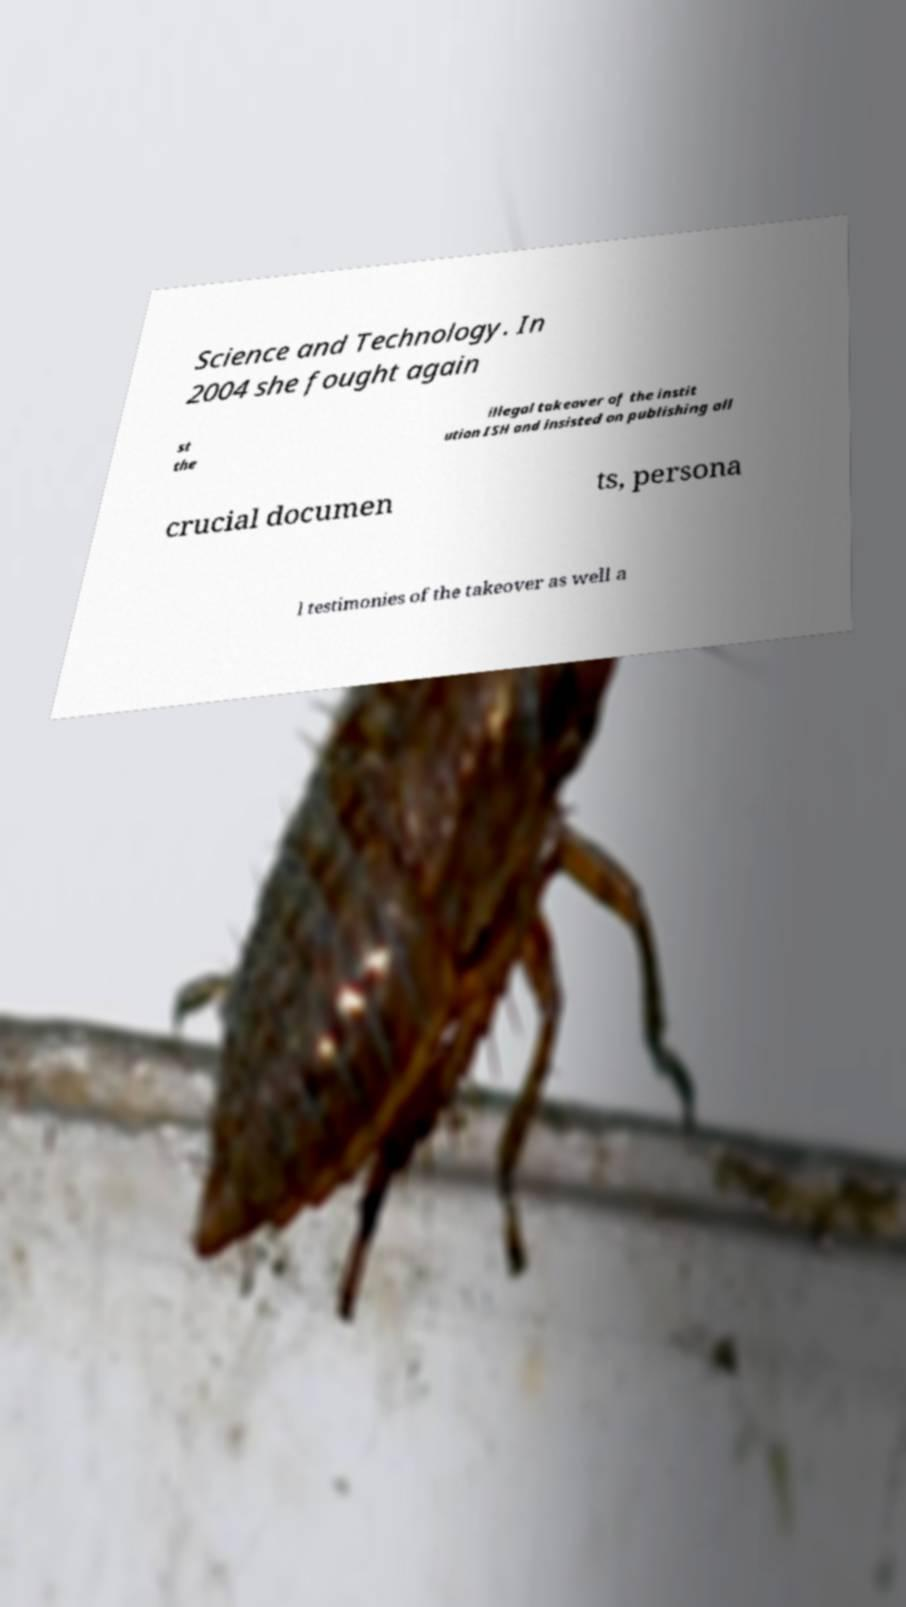I need the written content from this picture converted into text. Can you do that? Science and Technology. In 2004 she fought again st the illegal takeover of the instit ution ISH and insisted on publishing all crucial documen ts, persona l testimonies of the takeover as well a 